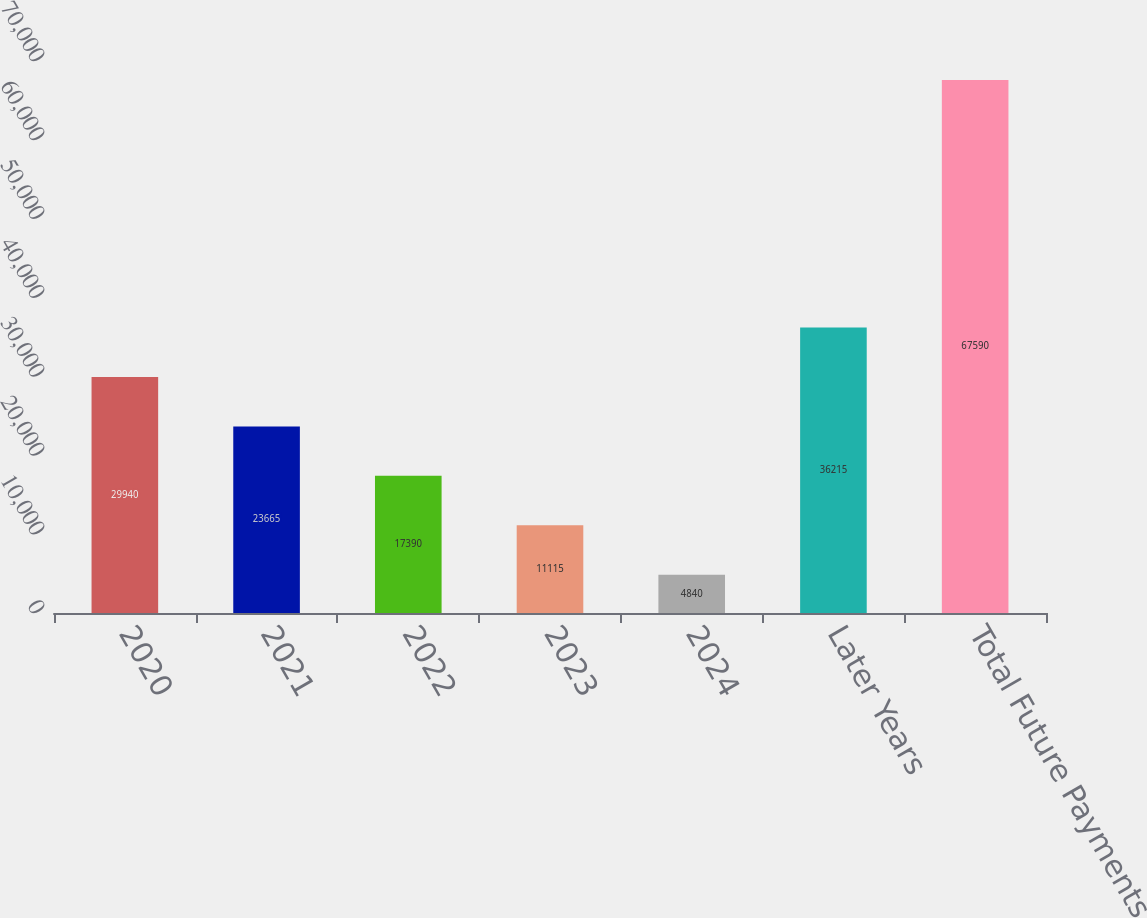Convert chart to OTSL. <chart><loc_0><loc_0><loc_500><loc_500><bar_chart><fcel>2020<fcel>2021<fcel>2022<fcel>2023<fcel>2024<fcel>Later Years<fcel>Total Future Payments<nl><fcel>29940<fcel>23665<fcel>17390<fcel>11115<fcel>4840<fcel>36215<fcel>67590<nl></chart> 